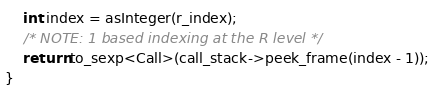<code> <loc_0><loc_0><loc_500><loc_500><_C++_>    int index = asInteger(r_index);
    /* NOTE: 1 based indexing at the R level */
    return to_sexp<Call>(call_stack->peek_frame(index - 1));
}
</code> 